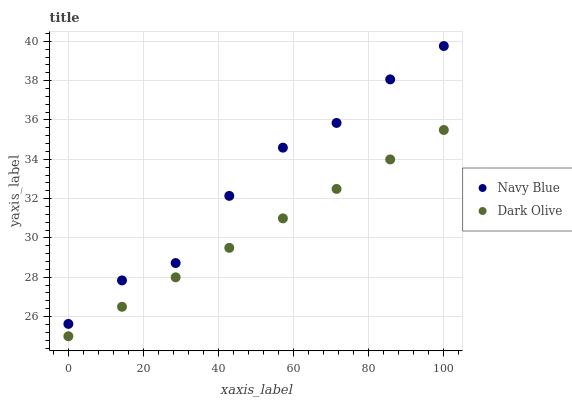Does Dark Olive have the minimum area under the curve?
Answer yes or no. Yes. Does Navy Blue have the maximum area under the curve?
Answer yes or no. Yes. Does Dark Olive have the maximum area under the curve?
Answer yes or no. No. Is Dark Olive the smoothest?
Answer yes or no. Yes. Is Navy Blue the roughest?
Answer yes or no. Yes. Is Dark Olive the roughest?
Answer yes or no. No. Does Dark Olive have the lowest value?
Answer yes or no. Yes. Does Navy Blue have the highest value?
Answer yes or no. Yes. Does Dark Olive have the highest value?
Answer yes or no. No. Is Dark Olive less than Navy Blue?
Answer yes or no. Yes. Is Navy Blue greater than Dark Olive?
Answer yes or no. Yes. Does Dark Olive intersect Navy Blue?
Answer yes or no. No. 